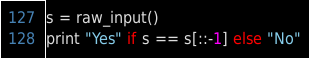Convert code to text. <code><loc_0><loc_0><loc_500><loc_500><_Python_>s = raw_input()
print "Yes" if s == s[::-1] else "No"
</code> 